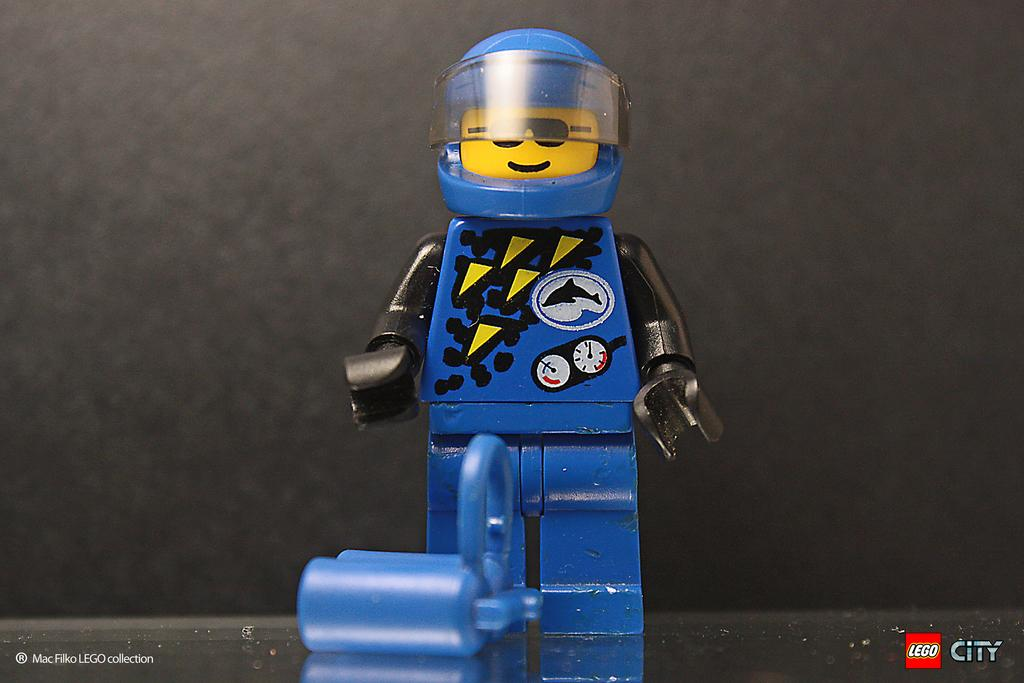What is the main subject in the middle of the image? There is a robot toy in the middle of the image. What can be seen in the background of the image? There is a wall in the background of the image. Where is the logo located in the image? The logo is in the bottom right corner of the image. What type of offer does the robot toy make to the viewer in the image? The robot toy does not make any offers to the viewer in the image, as it is an inanimate object. 